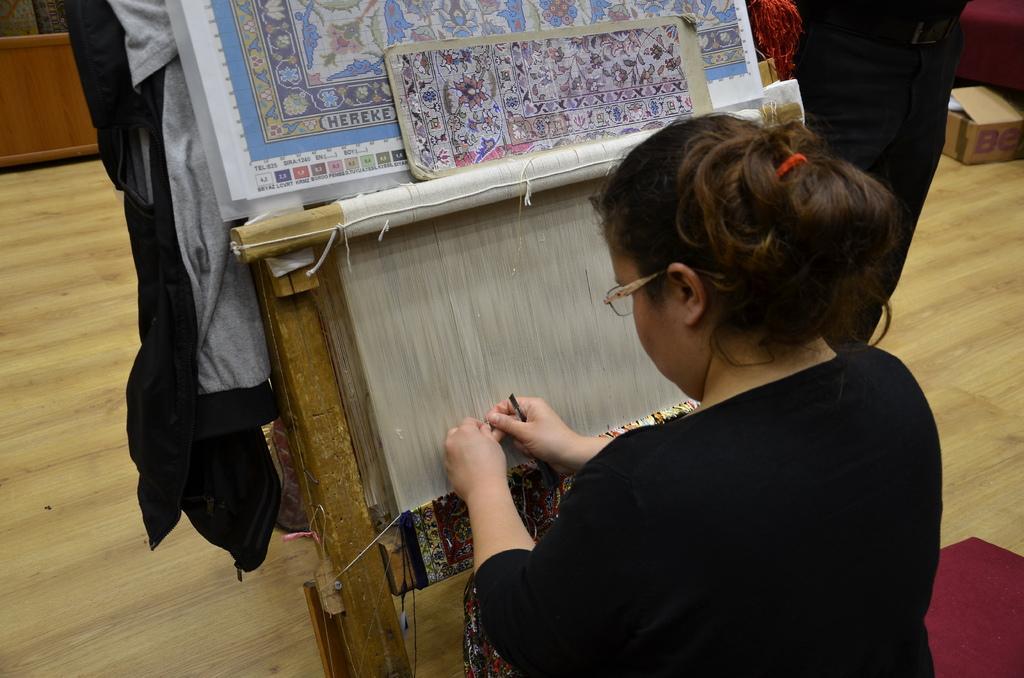Describe this image in one or two sentences. In this image in the foreground there is one woman, who is standing and she is doing something and in front of her there is a board and some threads and some clothes and some objects. And in the background there is box, wall and some objects, and in the bottom right hand corner there is carpet. At the bottom there is floor. 